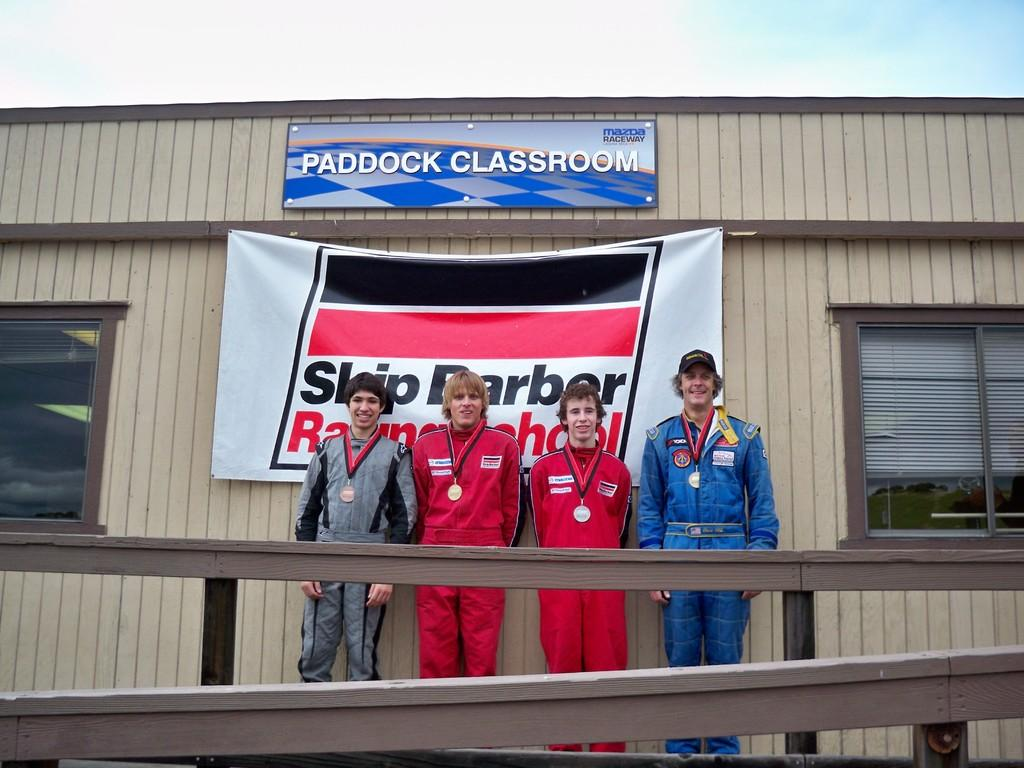How many people are in the image? There are four persons in the image. What are the persons doing in the image? The persons are standing in front of a building. What other object can be seen in the image besides the persons and the building? There is a notice board in the image. What is visible at the top of the image? The sky is visible at the top of the image. Can you tell me how many cows are standing next to the persons in the image? There are no cows present in the image; it only features four persons standing in front of a building. What type of lamp is hanging from the notice board in the image? There is no lamp present on or near the notice board in the image. 